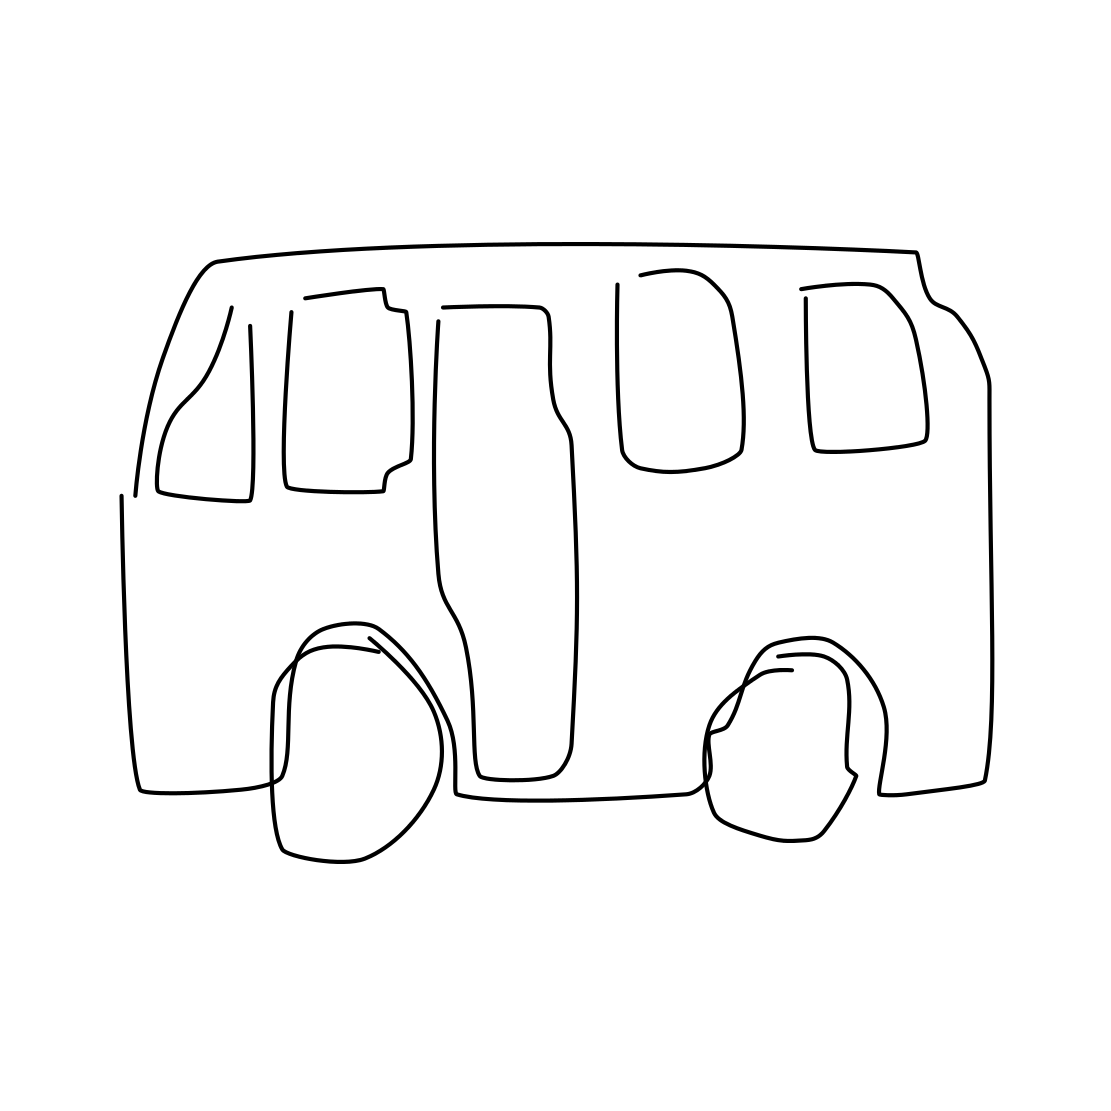In the scene, is a rifle in it? No 